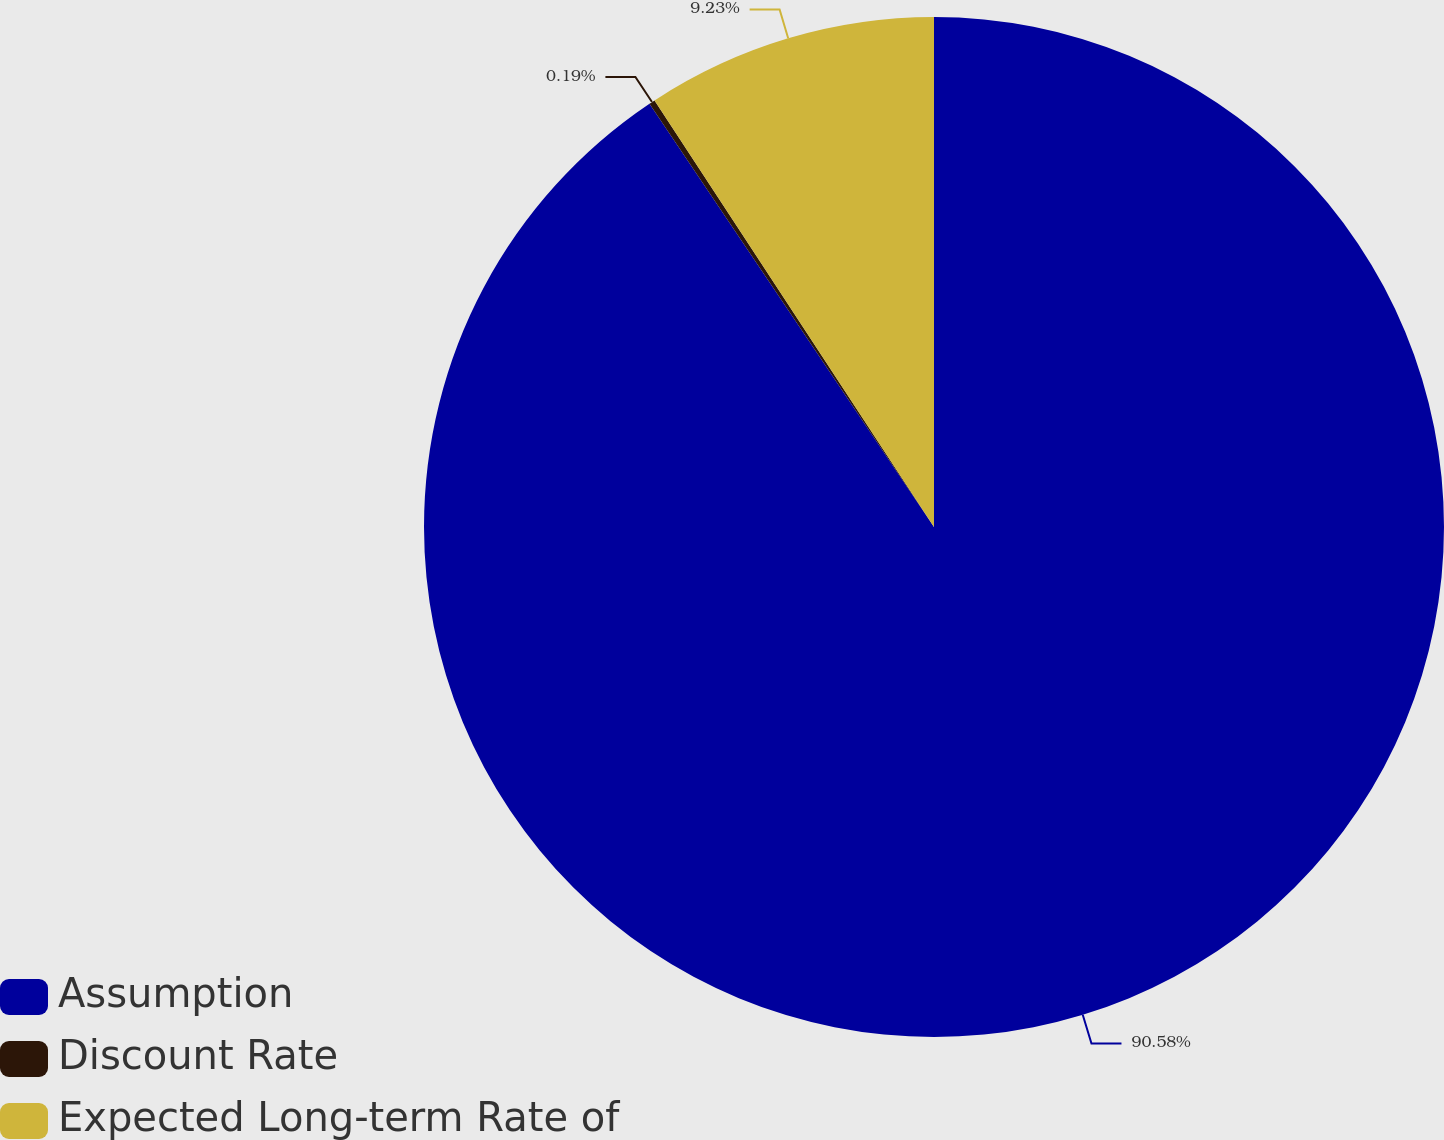<chart> <loc_0><loc_0><loc_500><loc_500><pie_chart><fcel>Assumption<fcel>Discount Rate<fcel>Expected Long-term Rate of<nl><fcel>90.58%<fcel>0.19%<fcel>9.23%<nl></chart> 